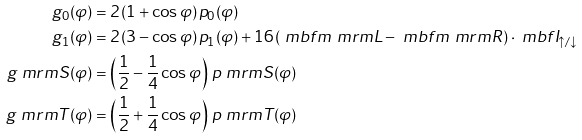<formula> <loc_0><loc_0><loc_500><loc_500>g _ { 0 } ( \varphi ) & = 2 \, ( 1 + \cos \varphi ) \, p _ { 0 } ( \varphi ) \\ g _ { 1 } ( \varphi ) & = 2 \, ( 3 - \cos \varphi ) \, p _ { 1 } ( \varphi ) + 1 6 \, ( \ m b f { m } _ { \ } m r m { L } - \ m b f { m } _ { \ } m r m { R } ) \cdot \ m b f { I } _ { \uparrow / \downarrow } \\ g _ { \ } m r m { S } ( \varphi ) & = \left ( \frac { 1 } { 2 } - \frac { 1 } { 4 } \cos \varphi \right ) \, p _ { \ } m r m { S } ( \varphi ) \\ g _ { \ } m r m { T } ( \varphi ) & = \left ( \frac { 1 } { 2 } + \frac { 1 } { 4 } \cos \varphi \right ) \, p _ { \ } m r m { T } ( \varphi )</formula> 